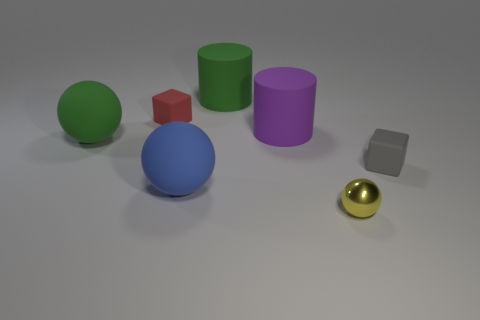There is a blue rubber object that is the same shape as the tiny yellow object; what is its size?
Ensure brevity in your answer.  Large. Do the rubber cylinder that is left of the purple object and the purple cylinder have the same size?
Make the answer very short. Yes. There is a sphere that is both on the right side of the red thing and behind the yellow metal object; how big is it?
Give a very brief answer. Large. Are there an equal number of small gray rubber objects in front of the yellow metallic thing and big brown objects?
Your answer should be compact. Yes. The small metal object is what color?
Provide a succinct answer. Yellow. There is a green cylinder that is made of the same material as the purple cylinder; what is its size?
Give a very brief answer. Large. What is the color of the other big sphere that is made of the same material as the green sphere?
Offer a terse response. Blue. Are there any gray cubes of the same size as the red thing?
Provide a short and direct response. Yes. There is a green object that is the same shape as the large blue rubber object; what is its material?
Your answer should be compact. Rubber. What is the shape of the purple matte object that is the same size as the blue object?
Provide a short and direct response. Cylinder. 